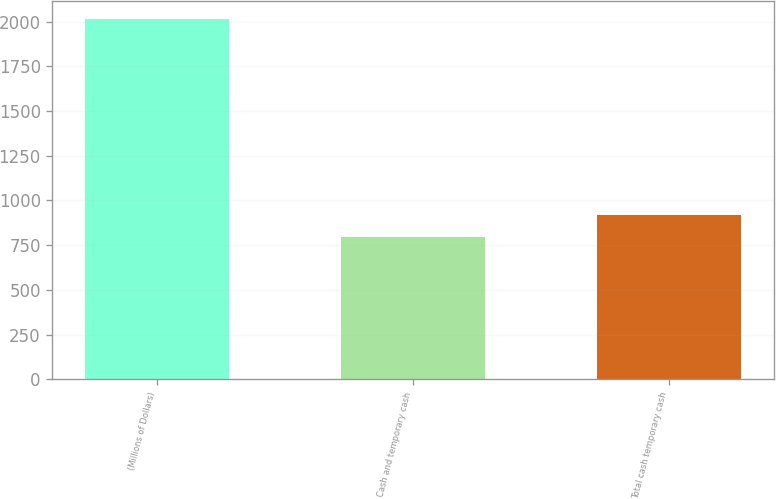Convert chart. <chart><loc_0><loc_0><loc_500><loc_500><bar_chart><fcel>(Millions of Dollars)<fcel>Cash and temporary cash<fcel>Total cash temporary cash<nl><fcel>2017<fcel>797<fcel>919<nl></chart> 